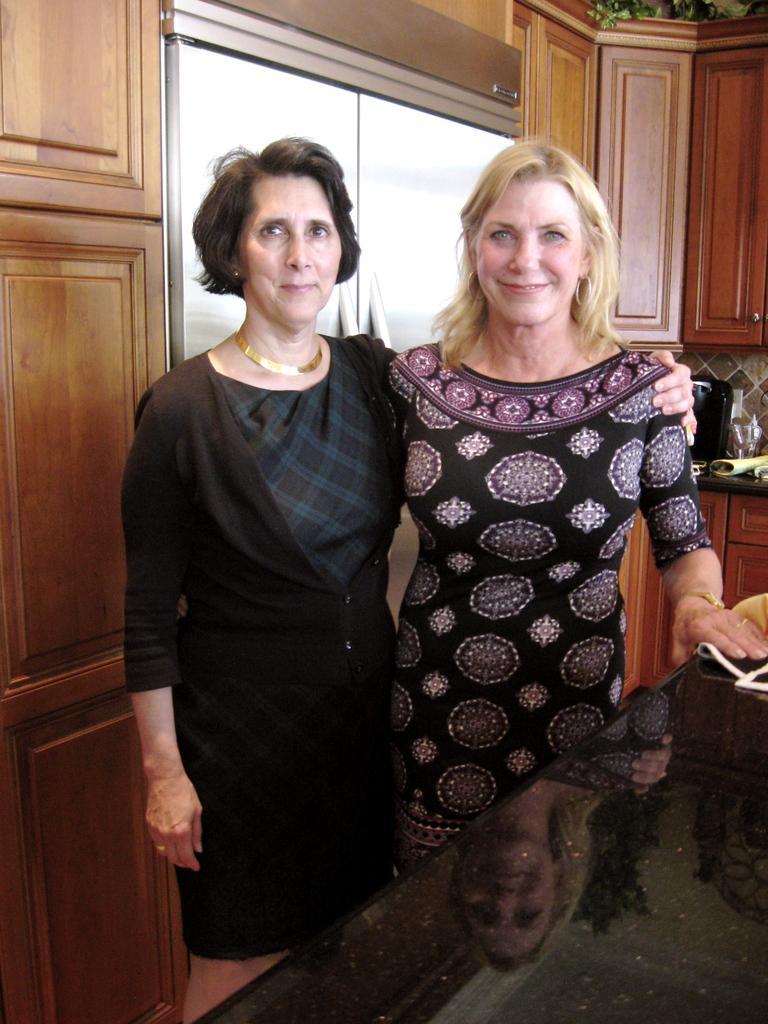How would you summarize this image in a sentence or two? In the image we can see there are two women standing, wearing clothes and they are smiling. This is a neck chain, earrings, finger ring, wrist watch, black marble sheet, wooden cupboards and leaves. 